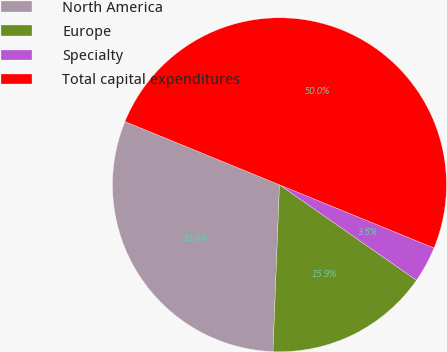Convert chart. <chart><loc_0><loc_0><loc_500><loc_500><pie_chart><fcel>North America<fcel>Europe<fcel>Specialty<fcel>Total capital expenditures<nl><fcel>30.57%<fcel>15.93%<fcel>3.51%<fcel>50.0%<nl></chart> 